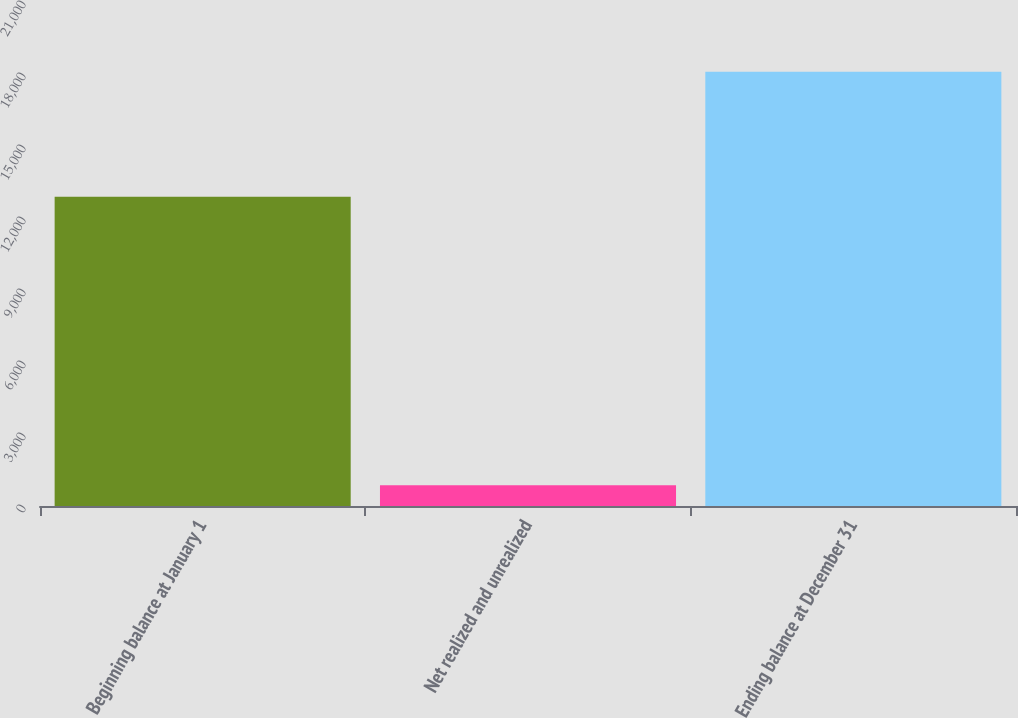Convert chart to OTSL. <chart><loc_0><loc_0><loc_500><loc_500><bar_chart><fcel>Beginning balance at January 1<fcel>Net realized and unrealized<fcel>Ending balance at December 31<nl><fcel>12881<fcel>866<fcel>18093<nl></chart> 